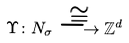Convert formula to latex. <formula><loc_0><loc_0><loc_500><loc_500>\Upsilon \colon N _ { \sigma } \overset { \cong } { \longrightarrow } \mathbb { Z } ^ { d }</formula> 